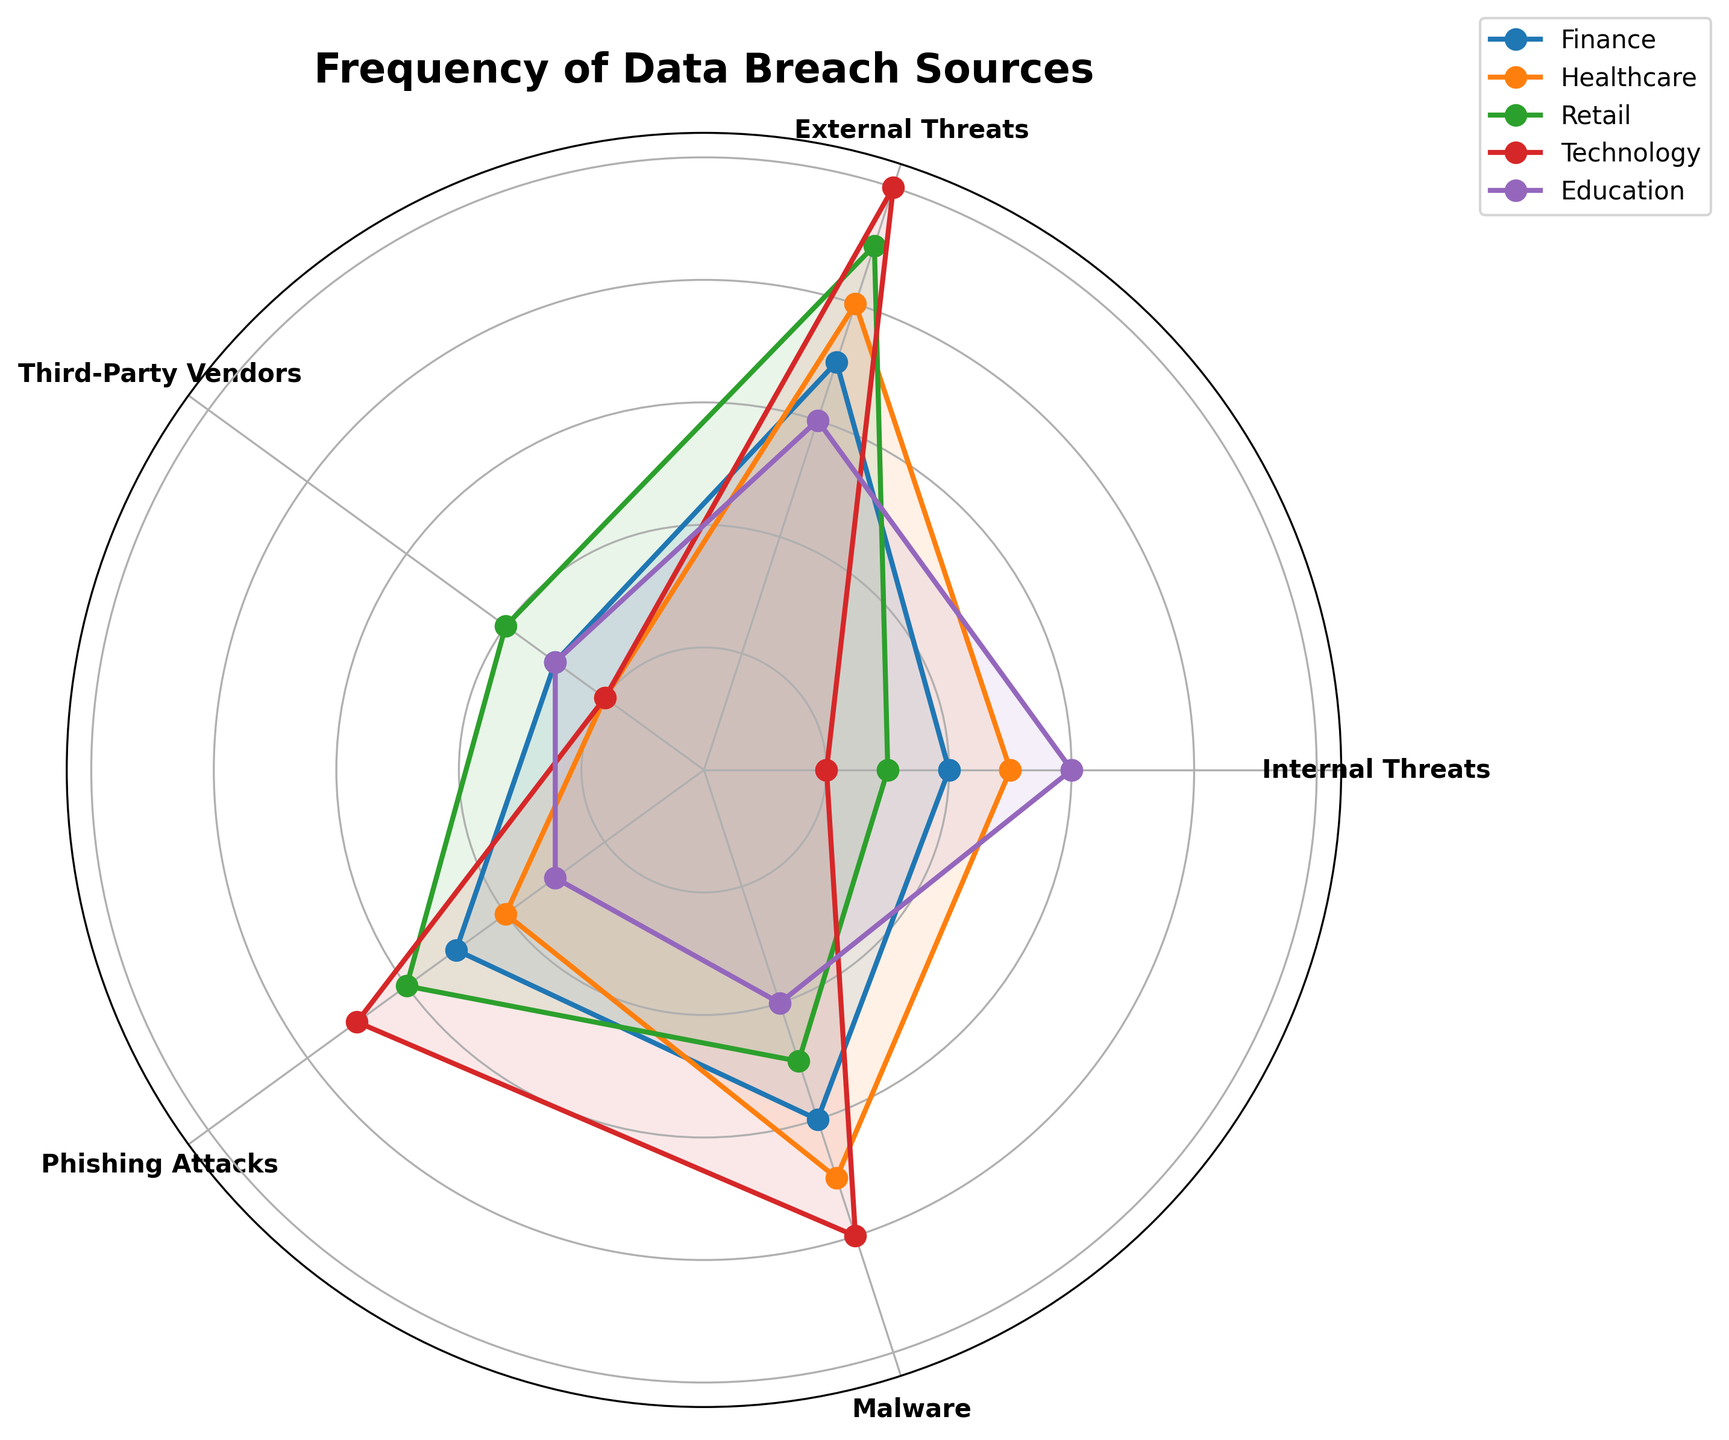What is the title of the figure? The title is located at the top of the figure, summarizing its content.
Answer: Frequency of Data Breach Sources Which category shows the highest frequency for External Threats? Identify the category with the longest line in the External Threats section of the radar chart.
Answer: Technology How many categories are represented in the figure? Count the number of distinct labeled lines (categories) in the radar chart.
Answer: Five What is the combined frequency of Internal Threats and Phishing Attacks for the Finance category? Add the frequencies of Internal Threats and Phishing Attacks for Finance (20 + 25).
Answer: 45 Which data breach source has the lowest frequency in the Technology category? Identify the segment with the shortest line in the Technology category.
Answer: Internal Threats Which category has equal frequencies for Internal Threats and Third-Party Vendors? Find the category where the two data points for Internal Threats and Third-Party Vendors align on the radar chart.
Answer: Education Compare the frequencies of Malware attacks in Healthcare and Retail categories. Locate and compare the frequencies in the Malware section for Healthcare and Retail.
Answer: Healthcare > Retail Which sector has the smallest difference between Internal Threats and External Threats? Calculate the differences for each sector and identify the smallest one. (Education: 0, Finance: 15, Healthcare: 15, Retail: 30, Technology: 40)
Answer: Education Out of all categories, which has the highest overall frequency for Phishing Attacks? Look for the longest line in the Phishing Attacks segment across all categories.
Answer: Technology What is the average frequency of Third-Party Vendors for all categories? Sum the frequencies for Third-Party Vendors across all categories and divide by the number of categories ((15 + 10 + 20 + 10 + 15) / 5).
Answer: 14 